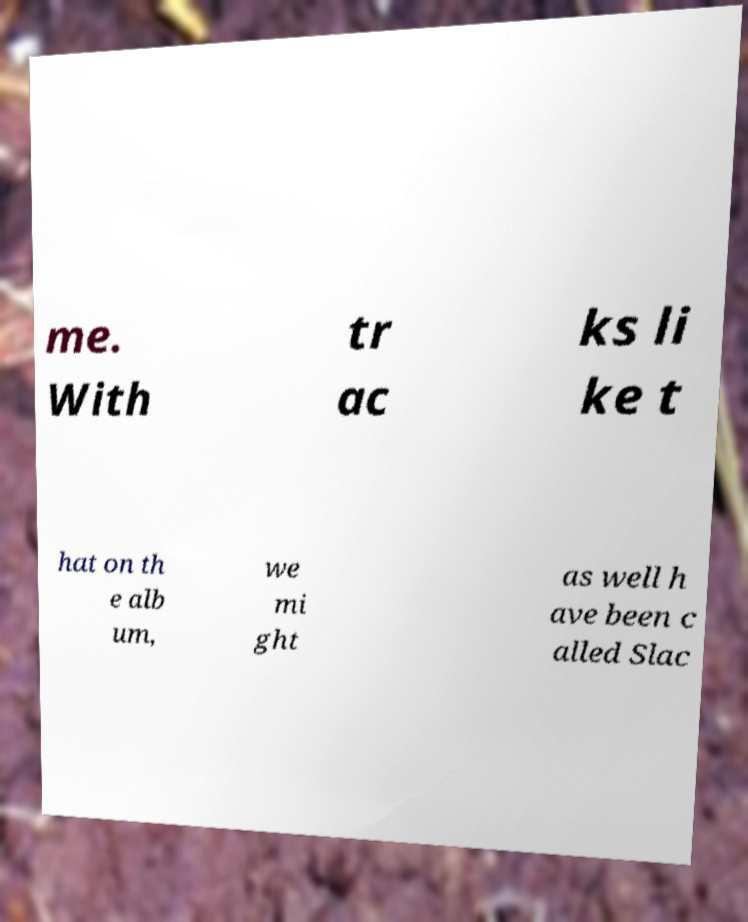For documentation purposes, I need the text within this image transcribed. Could you provide that? me. With tr ac ks li ke t hat on th e alb um, we mi ght as well h ave been c alled Slac 